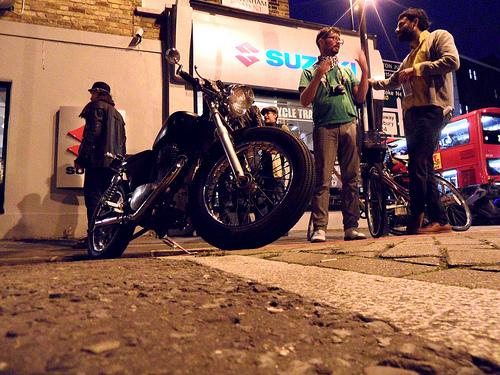Choose a person in the image and provide a description of their appearance. A man in a green shirt is light skinned and he has spectacles, standing near a rocky gray floor. Which two people can be referred to in the image, and what are they wearing? You can refer to a man in a green shirt and a man in a yellow shirt, both standing near a motorcycle. Describe the presence of any other person in the image and their features. There is a man in a yellow shirt standing outside, with his shoe being visible on his foot. Mention an unusual place where a brand name is written and the brand name itself. Suzuki is written on the wall, which is an unusual place for a brand name. Based on the details in the image, what type of setting do you think this scene takes place in, and why? The scene takes place on a busy street, as there is a parked motorcycle with a lit up bus, a man in a green shirt, and a man in a yellow shirt standing outside. What is the most significant object in the image related to transportation, and what are some of its unique features? The most significant object related to transportation in the image is the black motorcycle, which has chrome accents, handlebars, front and back wheels, and a headlight. Write a short advertisement for the motorcycle shown in the image. Introducing the sleek black motorcycle with eye-catching chrome accents, featuring handlebars, front and back wheels, and a bright headlight for safety. Ride in style and turn heads on this stunning bike! Identify any visible parts of the motorcycle in the image. Visible parts of the motorcycle include handlebars, front and back wheels, headlight, and chrome accents. What type of vehicle is prominently shown in the image and how can it be identified? A motorcycle is prominently shown in the image, identified by its handlebars, front and back wheels, headlight, and chrome accents. Identify the type of vehicle parked in the scene and describe its appearance. A black motorcycle is parked, featuring chrome accents, a front wheel, a back wheel, handlebars, and headlight. 